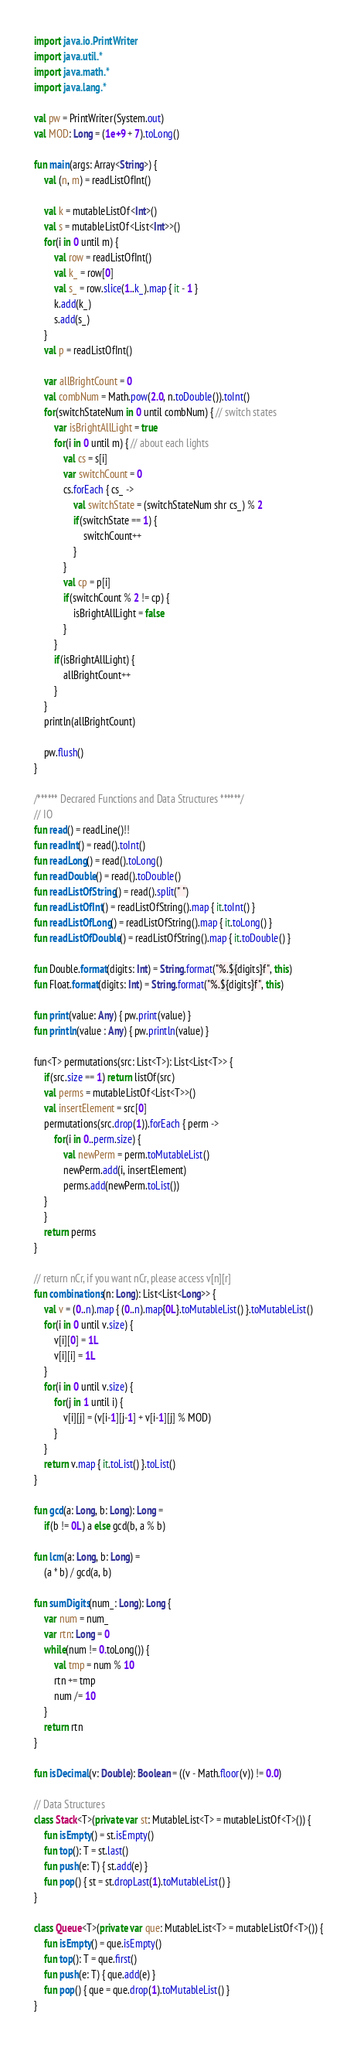<code> <loc_0><loc_0><loc_500><loc_500><_Kotlin_>import java.io.PrintWriter
import java.util.*
import java.math.*
import java.lang.*

val pw = PrintWriter(System.out)
val MOD: Long = (1e+9 + 7).toLong()

fun main(args: Array<String>) {
    val (n, m) = readListOfInt()
    
    val k = mutableListOf<Int>()
    val s = mutableListOf<List<Int>>()
    for(i in 0 until m) {
        val row = readListOfInt() 
        val k_ = row[0] 
        val s_ = row.slice(1..k_).map { it - 1 }
        k.add(k_)
        s.add(s_)
    }
    val p = readListOfInt()

    var allBrightCount = 0
    val combNum = Math.pow(2.0, n.toDouble()).toInt()
    for(switchStateNum in 0 until combNum) { // switch states
        var isBrightAllLight = true
        for(i in 0 until m) { // about each lights
            val cs = s[i]
            var switchCount = 0
            cs.forEach { cs_ ->
                val switchState = (switchStateNum shr cs_) % 2
                if(switchState == 1) {
                    switchCount++
                }
            }
            val cp = p[i]
            if(switchCount % 2 != cp) {
                isBrightAllLight = false
            }
        }
        if(isBrightAllLight) {
            allBrightCount++
        }
    }
    println(allBrightCount)

    pw.flush()
}

/****** Decrared Functions and Data Structures ******/
// IO
fun read() = readLine()!!
fun readInt() = read().toInt()
fun readLong() = read().toLong()
fun readDouble() = read().toDouble()
fun readListOfString() = read().split(" ")
fun readListOfInt() = readListOfString().map { it.toInt() }
fun readListOfLong() = readListOfString().map { it.toLong() }
fun readListOfDouble() = readListOfString().map { it.toDouble() }

fun Double.format(digits: Int) = String.format("%.${digits}f", this)
fun Float.format(digits: Int) = String.format("%.${digits}f", this)

fun print(value: Any) { pw.print(value) }
fun println(value : Any) { pw.println(value) }

fun<T> permutations(src: List<T>): List<List<T>> {
    if(src.size == 1) return listOf(src)
    val perms = mutableListOf<List<T>>()
    val insertElement = src[0]
    permutations(src.drop(1)).forEach { perm ->
        for(i in 0..perm.size) {
            val newPerm = perm.toMutableList()
            newPerm.add(i, insertElement)
            perms.add(newPerm.toList())
    }
    }
    return perms
}

// return nCr, if you want nCr, please access v[n][r]
fun combinations(n: Long): List<List<Long>> {
    val v = (0..n).map { (0..n).map{0L}.toMutableList() }.toMutableList()
    for(i in 0 until v.size) {
        v[i][0] = 1L
        v[i][i] = 1L
    }
    for(i in 0 until v.size) {
        for(j in 1 until i) {
            v[i][j] = (v[i-1][j-1] + v[i-1][j] % MOD)
        }
    }
    return v.map { it.toList() }.toList()
}

fun gcd(a: Long, b: Long): Long = 
    if(b != 0L) a else gcd(b, a % b)

fun lcm(a: Long, b: Long) = 
    (a * b) / gcd(a, b)

fun sumDigits(num_: Long): Long {
    var num = num_
    var rtn: Long = 0
    while(num != 0.toLong()) {
        val tmp = num % 10
        rtn += tmp
        num /= 10
    }
    return rtn
}

fun isDecimal(v: Double): Boolean = ((v - Math.floor(v)) != 0.0)

// Data Structures
class Stack<T>(private var st: MutableList<T> = mutableListOf<T>()) {
    fun isEmpty() = st.isEmpty()
    fun top(): T = st.last()
    fun push(e: T) { st.add(e) }
    fun pop() { st = st.dropLast(1).toMutableList() }
}

class Queue<T>(private var que: MutableList<T> = mutableListOf<T>()) {
    fun isEmpty() = que.isEmpty()
    fun top(): T = que.first()
    fun push(e: T) { que.add(e) }
    fun pop() { que = que.drop(1).toMutableList() }
}
</code> 